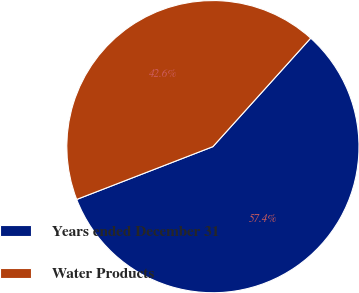Convert chart to OTSL. <chart><loc_0><loc_0><loc_500><loc_500><pie_chart><fcel>Years ended December 31<fcel>Water Products<nl><fcel>57.44%<fcel>42.56%<nl></chart> 